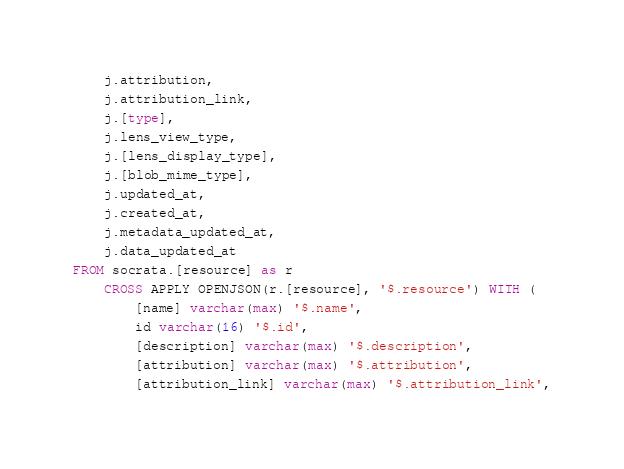<code> <loc_0><loc_0><loc_500><loc_500><_SQL_>    j.attribution,
    j.attribution_link,
    j.[type],
    j.lens_view_type,
    j.[lens_display_type],
    j.[blob_mime_type],
    j.updated_at,
    j.created_at,
    j.metadata_updated_at,
    j.data_updated_at
FROM socrata.[resource] as r
    CROSS APPLY OPENJSON(r.[resource], '$.resource') WITH (
        [name] varchar(max) '$.name',
        id varchar(16) '$.id',
        [description] varchar(max) '$.description',
        [attribution] varchar(max) '$.attribution',
        [attribution_link] varchar(max) '$.attribution_link',</code> 